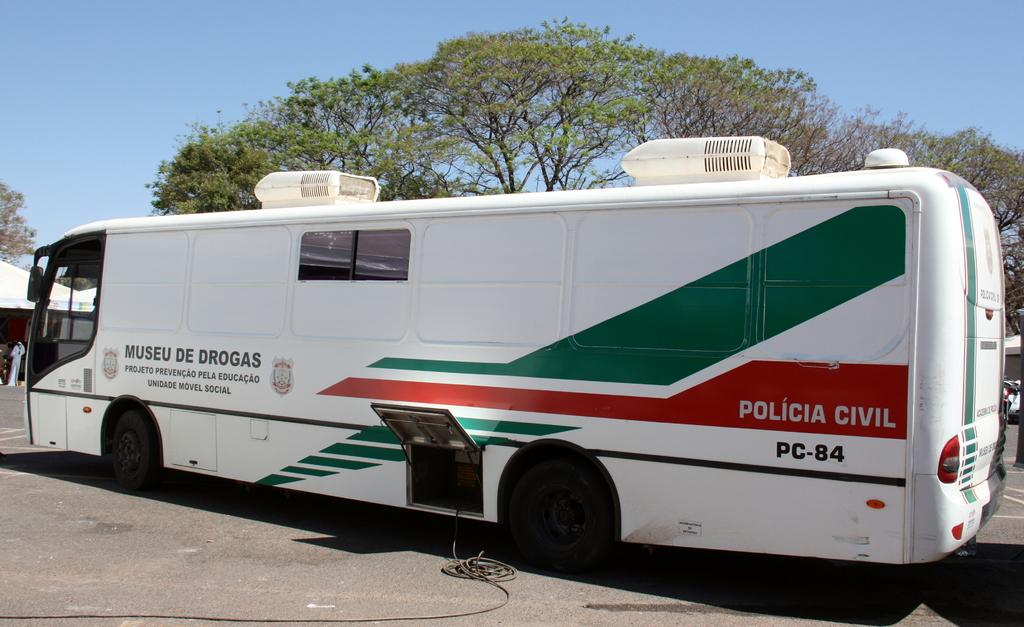Provide a one-sentence caption for the provided image. a big white bus with green and red for the Policia Civil. 